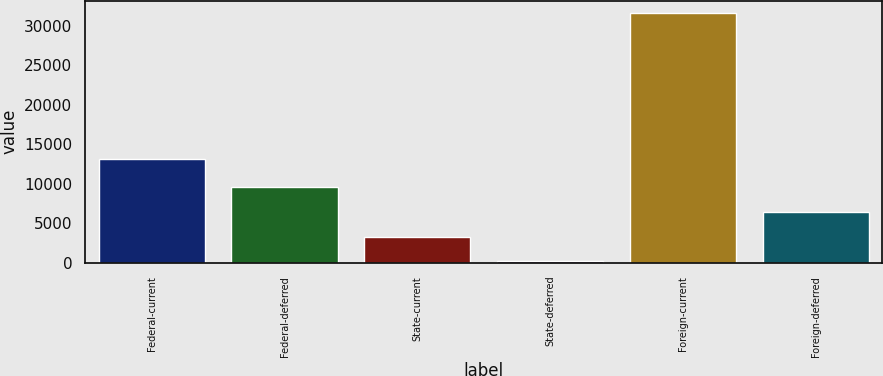<chart> <loc_0><loc_0><loc_500><loc_500><bar_chart><fcel>Federal-current<fcel>Federal-deferred<fcel>State-current<fcel>State-deferred<fcel>Foreign-current<fcel>Foreign-deferred<nl><fcel>13083<fcel>9584.9<fcel>3300.3<fcel>158<fcel>31581<fcel>6442.6<nl></chart> 